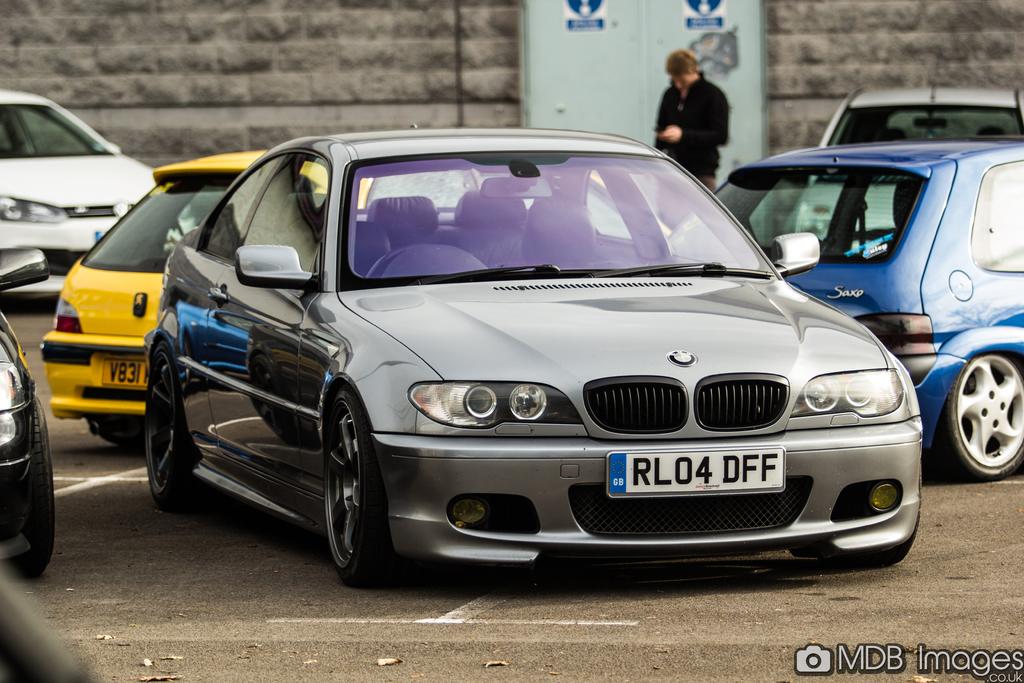What is the car's license plate?
Offer a very short reply. Rl04dff. 